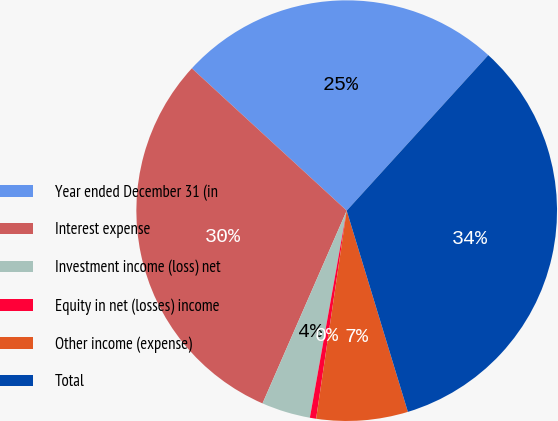Convert chart. <chart><loc_0><loc_0><loc_500><loc_500><pie_chart><fcel>Year ended December 31 (in<fcel>Interest expense<fcel>Investment income (loss) net<fcel>Equity in net (losses) income<fcel>Other income (expense)<fcel>Total<nl><fcel>24.92%<fcel>30.27%<fcel>3.75%<fcel>0.48%<fcel>7.02%<fcel>33.54%<nl></chart> 